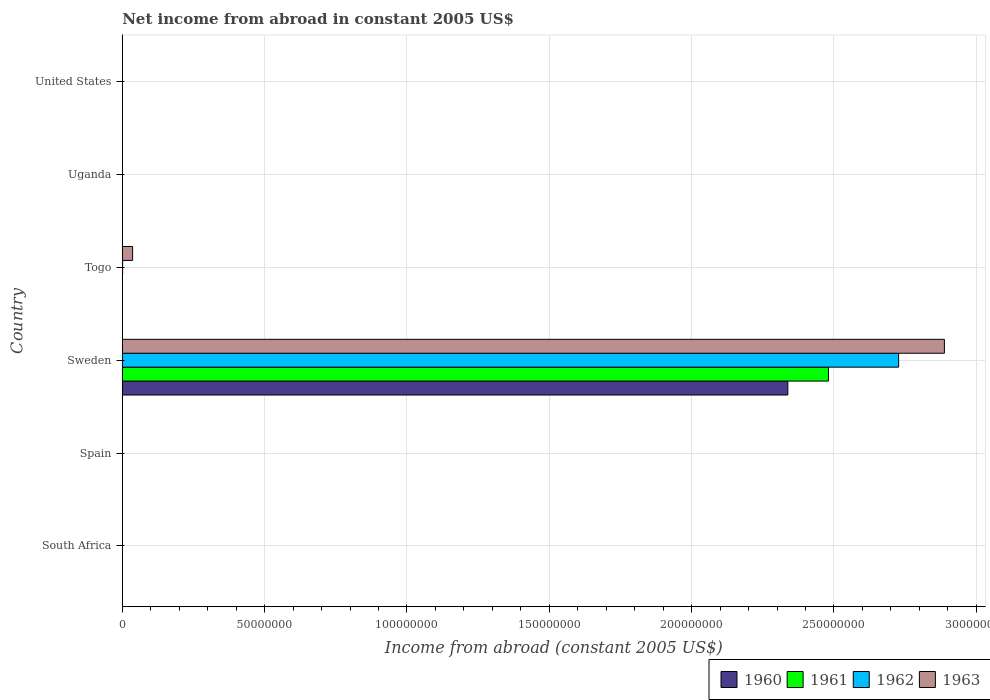Are the number of bars on each tick of the Y-axis equal?
Your response must be concise. No. How many bars are there on the 5th tick from the bottom?
Provide a short and direct response. 0. What is the label of the 1st group of bars from the top?
Keep it short and to the point. United States. Across all countries, what is the maximum net income from abroad in 1962?
Your answer should be compact. 2.73e+08. In which country was the net income from abroad in 1960 maximum?
Offer a terse response. Sweden. What is the total net income from abroad in 1960 in the graph?
Provide a succinct answer. 2.34e+08. What is the difference between the net income from abroad in 1961 in Sweden and the net income from abroad in 1962 in Spain?
Keep it short and to the point. 2.48e+08. What is the average net income from abroad in 1963 per country?
Offer a terse response. 4.87e+07. What is the difference between the net income from abroad in 1962 and net income from abroad in 1961 in Sweden?
Offer a very short reply. 2.46e+07. In how many countries, is the net income from abroad in 1962 greater than 290000000 US$?
Give a very brief answer. 0. What is the ratio of the net income from abroad in 1963 in Sweden to that in Togo?
Make the answer very short. 79.67. What is the difference between the highest and the lowest net income from abroad in 1961?
Your answer should be very brief. 2.48e+08. Are all the bars in the graph horizontal?
Your answer should be very brief. Yes. How many countries are there in the graph?
Your answer should be very brief. 6. What is the difference between two consecutive major ticks on the X-axis?
Your response must be concise. 5.00e+07. Are the values on the major ticks of X-axis written in scientific E-notation?
Provide a short and direct response. No. Does the graph contain any zero values?
Your answer should be very brief. Yes. How are the legend labels stacked?
Offer a very short reply. Horizontal. What is the title of the graph?
Your answer should be compact. Net income from abroad in constant 2005 US$. What is the label or title of the X-axis?
Give a very brief answer. Income from abroad (constant 2005 US$). What is the Income from abroad (constant 2005 US$) of 1960 in South Africa?
Provide a short and direct response. 0. What is the Income from abroad (constant 2005 US$) of 1962 in South Africa?
Offer a terse response. 0. What is the Income from abroad (constant 2005 US$) in 1960 in Spain?
Offer a terse response. 0. What is the Income from abroad (constant 2005 US$) in 1961 in Spain?
Make the answer very short. 0. What is the Income from abroad (constant 2005 US$) in 1962 in Spain?
Make the answer very short. 0. What is the Income from abroad (constant 2005 US$) of 1963 in Spain?
Your response must be concise. 0. What is the Income from abroad (constant 2005 US$) of 1960 in Sweden?
Your response must be concise. 2.34e+08. What is the Income from abroad (constant 2005 US$) in 1961 in Sweden?
Keep it short and to the point. 2.48e+08. What is the Income from abroad (constant 2005 US$) in 1962 in Sweden?
Give a very brief answer. 2.73e+08. What is the Income from abroad (constant 2005 US$) in 1963 in Sweden?
Your answer should be compact. 2.89e+08. What is the Income from abroad (constant 2005 US$) of 1962 in Togo?
Give a very brief answer. 1.22e+05. What is the Income from abroad (constant 2005 US$) of 1963 in Togo?
Provide a succinct answer. 3.62e+06. What is the Income from abroad (constant 2005 US$) in 1960 in Uganda?
Your answer should be compact. 0. What is the Income from abroad (constant 2005 US$) in 1961 in Uganda?
Your response must be concise. 0. What is the Income from abroad (constant 2005 US$) in 1963 in Uganda?
Your answer should be very brief. 0. What is the Income from abroad (constant 2005 US$) in 1960 in United States?
Keep it short and to the point. 0. What is the Income from abroad (constant 2005 US$) in 1962 in United States?
Offer a very short reply. 0. What is the Income from abroad (constant 2005 US$) in 1963 in United States?
Offer a very short reply. 0. Across all countries, what is the maximum Income from abroad (constant 2005 US$) of 1960?
Your answer should be very brief. 2.34e+08. Across all countries, what is the maximum Income from abroad (constant 2005 US$) in 1961?
Make the answer very short. 2.48e+08. Across all countries, what is the maximum Income from abroad (constant 2005 US$) in 1962?
Keep it short and to the point. 2.73e+08. Across all countries, what is the maximum Income from abroad (constant 2005 US$) of 1963?
Offer a terse response. 2.89e+08. Across all countries, what is the minimum Income from abroad (constant 2005 US$) in 1960?
Offer a terse response. 0. Across all countries, what is the minimum Income from abroad (constant 2005 US$) of 1961?
Keep it short and to the point. 0. Across all countries, what is the minimum Income from abroad (constant 2005 US$) of 1963?
Provide a short and direct response. 0. What is the total Income from abroad (constant 2005 US$) of 1960 in the graph?
Give a very brief answer. 2.34e+08. What is the total Income from abroad (constant 2005 US$) of 1961 in the graph?
Ensure brevity in your answer.  2.48e+08. What is the total Income from abroad (constant 2005 US$) in 1962 in the graph?
Keep it short and to the point. 2.73e+08. What is the total Income from abroad (constant 2005 US$) in 1963 in the graph?
Provide a short and direct response. 2.92e+08. What is the difference between the Income from abroad (constant 2005 US$) of 1962 in Sweden and that in Togo?
Keep it short and to the point. 2.73e+08. What is the difference between the Income from abroad (constant 2005 US$) of 1963 in Sweden and that in Togo?
Your answer should be compact. 2.85e+08. What is the difference between the Income from abroad (constant 2005 US$) of 1960 in Sweden and the Income from abroad (constant 2005 US$) of 1962 in Togo?
Keep it short and to the point. 2.34e+08. What is the difference between the Income from abroad (constant 2005 US$) of 1960 in Sweden and the Income from abroad (constant 2005 US$) of 1963 in Togo?
Provide a short and direct response. 2.30e+08. What is the difference between the Income from abroad (constant 2005 US$) in 1961 in Sweden and the Income from abroad (constant 2005 US$) in 1962 in Togo?
Offer a very short reply. 2.48e+08. What is the difference between the Income from abroad (constant 2005 US$) of 1961 in Sweden and the Income from abroad (constant 2005 US$) of 1963 in Togo?
Offer a terse response. 2.44e+08. What is the difference between the Income from abroad (constant 2005 US$) in 1962 in Sweden and the Income from abroad (constant 2005 US$) in 1963 in Togo?
Give a very brief answer. 2.69e+08. What is the average Income from abroad (constant 2005 US$) in 1960 per country?
Offer a terse response. 3.90e+07. What is the average Income from abroad (constant 2005 US$) of 1961 per country?
Your response must be concise. 4.13e+07. What is the average Income from abroad (constant 2005 US$) in 1962 per country?
Provide a short and direct response. 4.55e+07. What is the average Income from abroad (constant 2005 US$) of 1963 per country?
Your response must be concise. 4.87e+07. What is the difference between the Income from abroad (constant 2005 US$) of 1960 and Income from abroad (constant 2005 US$) of 1961 in Sweden?
Provide a short and direct response. -1.43e+07. What is the difference between the Income from abroad (constant 2005 US$) in 1960 and Income from abroad (constant 2005 US$) in 1962 in Sweden?
Ensure brevity in your answer.  -3.89e+07. What is the difference between the Income from abroad (constant 2005 US$) of 1960 and Income from abroad (constant 2005 US$) of 1963 in Sweden?
Your answer should be compact. -5.50e+07. What is the difference between the Income from abroad (constant 2005 US$) of 1961 and Income from abroad (constant 2005 US$) of 1962 in Sweden?
Ensure brevity in your answer.  -2.46e+07. What is the difference between the Income from abroad (constant 2005 US$) of 1961 and Income from abroad (constant 2005 US$) of 1963 in Sweden?
Give a very brief answer. -4.07e+07. What is the difference between the Income from abroad (constant 2005 US$) in 1962 and Income from abroad (constant 2005 US$) in 1963 in Sweden?
Offer a terse response. -1.61e+07. What is the difference between the Income from abroad (constant 2005 US$) in 1962 and Income from abroad (constant 2005 US$) in 1963 in Togo?
Make the answer very short. -3.50e+06. What is the ratio of the Income from abroad (constant 2005 US$) in 1962 in Sweden to that in Togo?
Offer a terse response. 2230.99. What is the ratio of the Income from abroad (constant 2005 US$) in 1963 in Sweden to that in Togo?
Provide a short and direct response. 79.67. What is the difference between the highest and the lowest Income from abroad (constant 2005 US$) of 1960?
Keep it short and to the point. 2.34e+08. What is the difference between the highest and the lowest Income from abroad (constant 2005 US$) in 1961?
Ensure brevity in your answer.  2.48e+08. What is the difference between the highest and the lowest Income from abroad (constant 2005 US$) in 1962?
Keep it short and to the point. 2.73e+08. What is the difference between the highest and the lowest Income from abroad (constant 2005 US$) in 1963?
Give a very brief answer. 2.89e+08. 